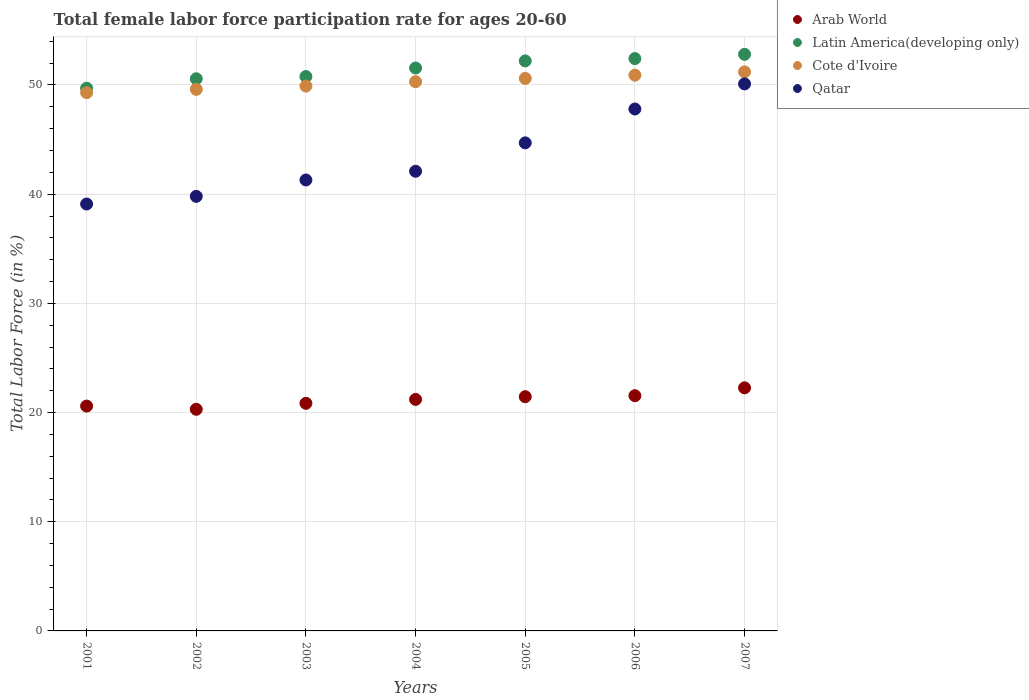What is the female labor force participation rate in Latin America(developing only) in 2006?
Give a very brief answer. 52.42. Across all years, what is the maximum female labor force participation rate in Latin America(developing only)?
Give a very brief answer. 52.81. Across all years, what is the minimum female labor force participation rate in Arab World?
Your response must be concise. 20.3. What is the total female labor force participation rate in Latin America(developing only) in the graph?
Give a very brief answer. 360.04. What is the difference between the female labor force participation rate in Arab World in 2003 and that in 2005?
Offer a very short reply. -0.61. What is the difference between the female labor force participation rate in Qatar in 2004 and the female labor force participation rate in Cote d'Ivoire in 2001?
Ensure brevity in your answer.  -7.2. What is the average female labor force participation rate in Arab World per year?
Your answer should be compact. 21.17. In the year 2003, what is the difference between the female labor force participation rate in Arab World and female labor force participation rate in Latin America(developing only)?
Your answer should be compact. -29.93. What is the ratio of the female labor force participation rate in Cote d'Ivoire in 2003 to that in 2004?
Ensure brevity in your answer.  0.99. What is the difference between the highest and the second highest female labor force participation rate in Qatar?
Make the answer very short. 2.3. What is the difference between the highest and the lowest female labor force participation rate in Arab World?
Give a very brief answer. 1.96. Is the sum of the female labor force participation rate in Qatar in 2002 and 2005 greater than the maximum female labor force participation rate in Latin America(developing only) across all years?
Your answer should be very brief. Yes. Is it the case that in every year, the sum of the female labor force participation rate in Qatar and female labor force participation rate in Latin America(developing only)  is greater than the female labor force participation rate in Arab World?
Offer a very short reply. Yes. Is the female labor force participation rate in Latin America(developing only) strictly less than the female labor force participation rate in Arab World over the years?
Make the answer very short. No. How many years are there in the graph?
Ensure brevity in your answer.  7. What is the difference between two consecutive major ticks on the Y-axis?
Offer a very short reply. 10. Does the graph contain any zero values?
Provide a succinct answer. No. Does the graph contain grids?
Provide a short and direct response. Yes. Where does the legend appear in the graph?
Your answer should be very brief. Top right. How are the legend labels stacked?
Offer a very short reply. Vertical. What is the title of the graph?
Provide a short and direct response. Total female labor force participation rate for ages 20-60. What is the label or title of the Y-axis?
Make the answer very short. Total Labor Force (in %). What is the Total Labor Force (in %) in Arab World in 2001?
Keep it short and to the point. 20.59. What is the Total Labor Force (in %) in Latin America(developing only) in 2001?
Your answer should be compact. 49.7. What is the Total Labor Force (in %) of Cote d'Ivoire in 2001?
Ensure brevity in your answer.  49.3. What is the Total Labor Force (in %) in Qatar in 2001?
Ensure brevity in your answer.  39.1. What is the Total Labor Force (in %) in Arab World in 2002?
Give a very brief answer. 20.3. What is the Total Labor Force (in %) of Latin America(developing only) in 2002?
Give a very brief answer. 50.57. What is the Total Labor Force (in %) in Cote d'Ivoire in 2002?
Offer a very short reply. 49.6. What is the Total Labor Force (in %) of Qatar in 2002?
Make the answer very short. 39.8. What is the Total Labor Force (in %) in Arab World in 2003?
Your answer should be very brief. 20.85. What is the Total Labor Force (in %) in Latin America(developing only) in 2003?
Your answer should be very brief. 50.77. What is the Total Labor Force (in %) of Cote d'Ivoire in 2003?
Your response must be concise. 49.9. What is the Total Labor Force (in %) of Qatar in 2003?
Your response must be concise. 41.3. What is the Total Labor Force (in %) of Arab World in 2004?
Your answer should be compact. 21.2. What is the Total Labor Force (in %) of Latin America(developing only) in 2004?
Ensure brevity in your answer.  51.55. What is the Total Labor Force (in %) of Cote d'Ivoire in 2004?
Ensure brevity in your answer.  50.3. What is the Total Labor Force (in %) in Qatar in 2004?
Provide a short and direct response. 42.1. What is the Total Labor Force (in %) in Arab World in 2005?
Offer a terse response. 21.45. What is the Total Labor Force (in %) of Latin America(developing only) in 2005?
Provide a short and direct response. 52.2. What is the Total Labor Force (in %) in Cote d'Ivoire in 2005?
Ensure brevity in your answer.  50.6. What is the Total Labor Force (in %) in Qatar in 2005?
Your answer should be very brief. 44.7. What is the Total Labor Force (in %) in Arab World in 2006?
Provide a short and direct response. 21.54. What is the Total Labor Force (in %) in Latin America(developing only) in 2006?
Your answer should be very brief. 52.42. What is the Total Labor Force (in %) of Cote d'Ivoire in 2006?
Provide a succinct answer. 50.9. What is the Total Labor Force (in %) of Qatar in 2006?
Offer a terse response. 47.8. What is the Total Labor Force (in %) of Arab World in 2007?
Provide a succinct answer. 22.26. What is the Total Labor Force (in %) in Latin America(developing only) in 2007?
Keep it short and to the point. 52.81. What is the Total Labor Force (in %) in Cote d'Ivoire in 2007?
Give a very brief answer. 51.2. What is the Total Labor Force (in %) of Qatar in 2007?
Your answer should be very brief. 50.1. Across all years, what is the maximum Total Labor Force (in %) of Arab World?
Ensure brevity in your answer.  22.26. Across all years, what is the maximum Total Labor Force (in %) of Latin America(developing only)?
Ensure brevity in your answer.  52.81. Across all years, what is the maximum Total Labor Force (in %) in Cote d'Ivoire?
Make the answer very short. 51.2. Across all years, what is the maximum Total Labor Force (in %) of Qatar?
Provide a short and direct response. 50.1. Across all years, what is the minimum Total Labor Force (in %) of Arab World?
Give a very brief answer. 20.3. Across all years, what is the minimum Total Labor Force (in %) of Latin America(developing only)?
Provide a succinct answer. 49.7. Across all years, what is the minimum Total Labor Force (in %) of Cote d'Ivoire?
Your answer should be compact. 49.3. Across all years, what is the minimum Total Labor Force (in %) in Qatar?
Offer a very short reply. 39.1. What is the total Total Labor Force (in %) in Arab World in the graph?
Offer a terse response. 148.2. What is the total Total Labor Force (in %) of Latin America(developing only) in the graph?
Make the answer very short. 360.04. What is the total Total Labor Force (in %) of Cote d'Ivoire in the graph?
Your answer should be compact. 351.8. What is the total Total Labor Force (in %) in Qatar in the graph?
Provide a succinct answer. 304.9. What is the difference between the Total Labor Force (in %) in Arab World in 2001 and that in 2002?
Offer a terse response. 0.29. What is the difference between the Total Labor Force (in %) of Latin America(developing only) in 2001 and that in 2002?
Provide a short and direct response. -0.87. What is the difference between the Total Labor Force (in %) in Cote d'Ivoire in 2001 and that in 2002?
Ensure brevity in your answer.  -0.3. What is the difference between the Total Labor Force (in %) of Arab World in 2001 and that in 2003?
Your response must be concise. -0.25. What is the difference between the Total Labor Force (in %) in Latin America(developing only) in 2001 and that in 2003?
Your answer should be very brief. -1.07. What is the difference between the Total Labor Force (in %) of Qatar in 2001 and that in 2003?
Give a very brief answer. -2.2. What is the difference between the Total Labor Force (in %) in Arab World in 2001 and that in 2004?
Your answer should be very brief. -0.61. What is the difference between the Total Labor Force (in %) in Latin America(developing only) in 2001 and that in 2004?
Your answer should be compact. -1.85. What is the difference between the Total Labor Force (in %) in Qatar in 2001 and that in 2004?
Keep it short and to the point. -3. What is the difference between the Total Labor Force (in %) of Arab World in 2001 and that in 2005?
Ensure brevity in your answer.  -0.86. What is the difference between the Total Labor Force (in %) in Latin America(developing only) in 2001 and that in 2005?
Ensure brevity in your answer.  -2.5. What is the difference between the Total Labor Force (in %) of Cote d'Ivoire in 2001 and that in 2005?
Provide a short and direct response. -1.3. What is the difference between the Total Labor Force (in %) of Qatar in 2001 and that in 2005?
Make the answer very short. -5.6. What is the difference between the Total Labor Force (in %) in Arab World in 2001 and that in 2006?
Provide a succinct answer. -0.95. What is the difference between the Total Labor Force (in %) of Latin America(developing only) in 2001 and that in 2006?
Keep it short and to the point. -2.72. What is the difference between the Total Labor Force (in %) of Arab World in 2001 and that in 2007?
Keep it short and to the point. -1.67. What is the difference between the Total Labor Force (in %) in Latin America(developing only) in 2001 and that in 2007?
Your answer should be compact. -3.11. What is the difference between the Total Labor Force (in %) in Qatar in 2001 and that in 2007?
Ensure brevity in your answer.  -11. What is the difference between the Total Labor Force (in %) in Arab World in 2002 and that in 2003?
Provide a short and direct response. -0.55. What is the difference between the Total Labor Force (in %) in Latin America(developing only) in 2002 and that in 2003?
Provide a short and direct response. -0.2. What is the difference between the Total Labor Force (in %) of Qatar in 2002 and that in 2003?
Make the answer very short. -1.5. What is the difference between the Total Labor Force (in %) in Arab World in 2002 and that in 2004?
Ensure brevity in your answer.  -0.9. What is the difference between the Total Labor Force (in %) of Latin America(developing only) in 2002 and that in 2004?
Your answer should be compact. -0.98. What is the difference between the Total Labor Force (in %) in Cote d'Ivoire in 2002 and that in 2004?
Your response must be concise. -0.7. What is the difference between the Total Labor Force (in %) of Qatar in 2002 and that in 2004?
Offer a very short reply. -2.3. What is the difference between the Total Labor Force (in %) in Arab World in 2002 and that in 2005?
Ensure brevity in your answer.  -1.15. What is the difference between the Total Labor Force (in %) of Latin America(developing only) in 2002 and that in 2005?
Provide a succinct answer. -1.63. What is the difference between the Total Labor Force (in %) of Arab World in 2002 and that in 2006?
Offer a very short reply. -1.24. What is the difference between the Total Labor Force (in %) of Latin America(developing only) in 2002 and that in 2006?
Keep it short and to the point. -1.85. What is the difference between the Total Labor Force (in %) in Cote d'Ivoire in 2002 and that in 2006?
Offer a terse response. -1.3. What is the difference between the Total Labor Force (in %) of Arab World in 2002 and that in 2007?
Your response must be concise. -1.96. What is the difference between the Total Labor Force (in %) of Latin America(developing only) in 2002 and that in 2007?
Provide a succinct answer. -2.24. What is the difference between the Total Labor Force (in %) of Arab World in 2003 and that in 2004?
Offer a terse response. -0.36. What is the difference between the Total Labor Force (in %) of Latin America(developing only) in 2003 and that in 2004?
Offer a very short reply. -0.78. What is the difference between the Total Labor Force (in %) in Cote d'Ivoire in 2003 and that in 2004?
Offer a very short reply. -0.4. What is the difference between the Total Labor Force (in %) in Arab World in 2003 and that in 2005?
Make the answer very short. -0.61. What is the difference between the Total Labor Force (in %) of Latin America(developing only) in 2003 and that in 2005?
Your response must be concise. -1.43. What is the difference between the Total Labor Force (in %) in Arab World in 2003 and that in 2006?
Ensure brevity in your answer.  -0.7. What is the difference between the Total Labor Force (in %) of Latin America(developing only) in 2003 and that in 2006?
Offer a very short reply. -1.65. What is the difference between the Total Labor Force (in %) in Cote d'Ivoire in 2003 and that in 2006?
Provide a succinct answer. -1. What is the difference between the Total Labor Force (in %) in Qatar in 2003 and that in 2006?
Provide a succinct answer. -6.5. What is the difference between the Total Labor Force (in %) of Arab World in 2003 and that in 2007?
Provide a succinct answer. -1.42. What is the difference between the Total Labor Force (in %) in Latin America(developing only) in 2003 and that in 2007?
Make the answer very short. -2.04. What is the difference between the Total Labor Force (in %) of Cote d'Ivoire in 2003 and that in 2007?
Your answer should be compact. -1.3. What is the difference between the Total Labor Force (in %) of Qatar in 2003 and that in 2007?
Offer a terse response. -8.8. What is the difference between the Total Labor Force (in %) of Arab World in 2004 and that in 2005?
Offer a terse response. -0.25. What is the difference between the Total Labor Force (in %) in Latin America(developing only) in 2004 and that in 2005?
Provide a succinct answer. -0.65. What is the difference between the Total Labor Force (in %) of Cote d'Ivoire in 2004 and that in 2005?
Your answer should be compact. -0.3. What is the difference between the Total Labor Force (in %) of Qatar in 2004 and that in 2005?
Offer a terse response. -2.6. What is the difference between the Total Labor Force (in %) in Arab World in 2004 and that in 2006?
Offer a terse response. -0.34. What is the difference between the Total Labor Force (in %) of Latin America(developing only) in 2004 and that in 2006?
Your answer should be very brief. -0.86. What is the difference between the Total Labor Force (in %) in Cote d'Ivoire in 2004 and that in 2006?
Ensure brevity in your answer.  -0.6. What is the difference between the Total Labor Force (in %) in Qatar in 2004 and that in 2006?
Your answer should be compact. -5.7. What is the difference between the Total Labor Force (in %) in Arab World in 2004 and that in 2007?
Provide a succinct answer. -1.06. What is the difference between the Total Labor Force (in %) in Latin America(developing only) in 2004 and that in 2007?
Provide a succinct answer. -1.25. What is the difference between the Total Labor Force (in %) of Arab World in 2005 and that in 2006?
Offer a terse response. -0.09. What is the difference between the Total Labor Force (in %) of Latin America(developing only) in 2005 and that in 2006?
Offer a terse response. -0.21. What is the difference between the Total Labor Force (in %) in Cote d'Ivoire in 2005 and that in 2006?
Give a very brief answer. -0.3. What is the difference between the Total Labor Force (in %) in Arab World in 2005 and that in 2007?
Your response must be concise. -0.81. What is the difference between the Total Labor Force (in %) of Latin America(developing only) in 2005 and that in 2007?
Your response must be concise. -0.6. What is the difference between the Total Labor Force (in %) of Arab World in 2006 and that in 2007?
Ensure brevity in your answer.  -0.72. What is the difference between the Total Labor Force (in %) in Latin America(developing only) in 2006 and that in 2007?
Your answer should be very brief. -0.39. What is the difference between the Total Labor Force (in %) of Cote d'Ivoire in 2006 and that in 2007?
Offer a very short reply. -0.3. What is the difference between the Total Labor Force (in %) in Qatar in 2006 and that in 2007?
Give a very brief answer. -2.3. What is the difference between the Total Labor Force (in %) in Arab World in 2001 and the Total Labor Force (in %) in Latin America(developing only) in 2002?
Your answer should be compact. -29.98. What is the difference between the Total Labor Force (in %) in Arab World in 2001 and the Total Labor Force (in %) in Cote d'Ivoire in 2002?
Keep it short and to the point. -29.01. What is the difference between the Total Labor Force (in %) of Arab World in 2001 and the Total Labor Force (in %) of Qatar in 2002?
Make the answer very short. -19.21. What is the difference between the Total Labor Force (in %) of Latin America(developing only) in 2001 and the Total Labor Force (in %) of Cote d'Ivoire in 2002?
Offer a terse response. 0.1. What is the difference between the Total Labor Force (in %) in Latin America(developing only) in 2001 and the Total Labor Force (in %) in Qatar in 2002?
Make the answer very short. 9.9. What is the difference between the Total Labor Force (in %) of Cote d'Ivoire in 2001 and the Total Labor Force (in %) of Qatar in 2002?
Your answer should be compact. 9.5. What is the difference between the Total Labor Force (in %) in Arab World in 2001 and the Total Labor Force (in %) in Latin America(developing only) in 2003?
Your response must be concise. -30.18. What is the difference between the Total Labor Force (in %) of Arab World in 2001 and the Total Labor Force (in %) of Cote d'Ivoire in 2003?
Offer a very short reply. -29.31. What is the difference between the Total Labor Force (in %) of Arab World in 2001 and the Total Labor Force (in %) of Qatar in 2003?
Give a very brief answer. -20.71. What is the difference between the Total Labor Force (in %) in Latin America(developing only) in 2001 and the Total Labor Force (in %) in Cote d'Ivoire in 2003?
Your answer should be very brief. -0.2. What is the difference between the Total Labor Force (in %) in Latin America(developing only) in 2001 and the Total Labor Force (in %) in Qatar in 2003?
Give a very brief answer. 8.4. What is the difference between the Total Labor Force (in %) of Arab World in 2001 and the Total Labor Force (in %) of Latin America(developing only) in 2004?
Keep it short and to the point. -30.96. What is the difference between the Total Labor Force (in %) in Arab World in 2001 and the Total Labor Force (in %) in Cote d'Ivoire in 2004?
Your response must be concise. -29.71. What is the difference between the Total Labor Force (in %) of Arab World in 2001 and the Total Labor Force (in %) of Qatar in 2004?
Ensure brevity in your answer.  -21.51. What is the difference between the Total Labor Force (in %) in Latin America(developing only) in 2001 and the Total Labor Force (in %) in Cote d'Ivoire in 2004?
Give a very brief answer. -0.6. What is the difference between the Total Labor Force (in %) in Latin America(developing only) in 2001 and the Total Labor Force (in %) in Qatar in 2004?
Offer a terse response. 7.6. What is the difference between the Total Labor Force (in %) in Cote d'Ivoire in 2001 and the Total Labor Force (in %) in Qatar in 2004?
Offer a terse response. 7.2. What is the difference between the Total Labor Force (in %) of Arab World in 2001 and the Total Labor Force (in %) of Latin America(developing only) in 2005?
Ensure brevity in your answer.  -31.61. What is the difference between the Total Labor Force (in %) of Arab World in 2001 and the Total Labor Force (in %) of Cote d'Ivoire in 2005?
Provide a short and direct response. -30.01. What is the difference between the Total Labor Force (in %) of Arab World in 2001 and the Total Labor Force (in %) of Qatar in 2005?
Keep it short and to the point. -24.11. What is the difference between the Total Labor Force (in %) of Latin America(developing only) in 2001 and the Total Labor Force (in %) of Cote d'Ivoire in 2005?
Make the answer very short. -0.9. What is the difference between the Total Labor Force (in %) in Latin America(developing only) in 2001 and the Total Labor Force (in %) in Qatar in 2005?
Keep it short and to the point. 5. What is the difference between the Total Labor Force (in %) in Cote d'Ivoire in 2001 and the Total Labor Force (in %) in Qatar in 2005?
Keep it short and to the point. 4.6. What is the difference between the Total Labor Force (in %) of Arab World in 2001 and the Total Labor Force (in %) of Latin America(developing only) in 2006?
Ensure brevity in your answer.  -31.83. What is the difference between the Total Labor Force (in %) in Arab World in 2001 and the Total Labor Force (in %) in Cote d'Ivoire in 2006?
Your response must be concise. -30.31. What is the difference between the Total Labor Force (in %) in Arab World in 2001 and the Total Labor Force (in %) in Qatar in 2006?
Keep it short and to the point. -27.21. What is the difference between the Total Labor Force (in %) of Latin America(developing only) in 2001 and the Total Labor Force (in %) of Cote d'Ivoire in 2006?
Offer a very short reply. -1.2. What is the difference between the Total Labor Force (in %) in Latin America(developing only) in 2001 and the Total Labor Force (in %) in Qatar in 2006?
Your response must be concise. 1.9. What is the difference between the Total Labor Force (in %) in Arab World in 2001 and the Total Labor Force (in %) in Latin America(developing only) in 2007?
Offer a terse response. -32.22. What is the difference between the Total Labor Force (in %) of Arab World in 2001 and the Total Labor Force (in %) of Cote d'Ivoire in 2007?
Make the answer very short. -30.61. What is the difference between the Total Labor Force (in %) in Arab World in 2001 and the Total Labor Force (in %) in Qatar in 2007?
Ensure brevity in your answer.  -29.51. What is the difference between the Total Labor Force (in %) in Latin America(developing only) in 2001 and the Total Labor Force (in %) in Cote d'Ivoire in 2007?
Provide a short and direct response. -1.5. What is the difference between the Total Labor Force (in %) in Latin America(developing only) in 2001 and the Total Labor Force (in %) in Qatar in 2007?
Ensure brevity in your answer.  -0.4. What is the difference between the Total Labor Force (in %) in Cote d'Ivoire in 2001 and the Total Labor Force (in %) in Qatar in 2007?
Your answer should be very brief. -0.8. What is the difference between the Total Labor Force (in %) of Arab World in 2002 and the Total Labor Force (in %) of Latin America(developing only) in 2003?
Keep it short and to the point. -30.48. What is the difference between the Total Labor Force (in %) of Arab World in 2002 and the Total Labor Force (in %) of Cote d'Ivoire in 2003?
Make the answer very short. -29.6. What is the difference between the Total Labor Force (in %) of Arab World in 2002 and the Total Labor Force (in %) of Qatar in 2003?
Your answer should be very brief. -21. What is the difference between the Total Labor Force (in %) in Latin America(developing only) in 2002 and the Total Labor Force (in %) in Cote d'Ivoire in 2003?
Ensure brevity in your answer.  0.67. What is the difference between the Total Labor Force (in %) of Latin America(developing only) in 2002 and the Total Labor Force (in %) of Qatar in 2003?
Ensure brevity in your answer.  9.27. What is the difference between the Total Labor Force (in %) in Cote d'Ivoire in 2002 and the Total Labor Force (in %) in Qatar in 2003?
Ensure brevity in your answer.  8.3. What is the difference between the Total Labor Force (in %) of Arab World in 2002 and the Total Labor Force (in %) of Latin America(developing only) in 2004?
Give a very brief answer. -31.26. What is the difference between the Total Labor Force (in %) of Arab World in 2002 and the Total Labor Force (in %) of Cote d'Ivoire in 2004?
Offer a terse response. -30. What is the difference between the Total Labor Force (in %) of Arab World in 2002 and the Total Labor Force (in %) of Qatar in 2004?
Ensure brevity in your answer.  -21.8. What is the difference between the Total Labor Force (in %) of Latin America(developing only) in 2002 and the Total Labor Force (in %) of Cote d'Ivoire in 2004?
Provide a short and direct response. 0.27. What is the difference between the Total Labor Force (in %) in Latin America(developing only) in 2002 and the Total Labor Force (in %) in Qatar in 2004?
Your answer should be compact. 8.47. What is the difference between the Total Labor Force (in %) in Cote d'Ivoire in 2002 and the Total Labor Force (in %) in Qatar in 2004?
Offer a very short reply. 7.5. What is the difference between the Total Labor Force (in %) of Arab World in 2002 and the Total Labor Force (in %) of Latin America(developing only) in 2005?
Your response must be concise. -31.91. What is the difference between the Total Labor Force (in %) of Arab World in 2002 and the Total Labor Force (in %) of Cote d'Ivoire in 2005?
Your answer should be very brief. -30.3. What is the difference between the Total Labor Force (in %) in Arab World in 2002 and the Total Labor Force (in %) in Qatar in 2005?
Ensure brevity in your answer.  -24.4. What is the difference between the Total Labor Force (in %) of Latin America(developing only) in 2002 and the Total Labor Force (in %) of Cote d'Ivoire in 2005?
Keep it short and to the point. -0.03. What is the difference between the Total Labor Force (in %) in Latin America(developing only) in 2002 and the Total Labor Force (in %) in Qatar in 2005?
Your answer should be compact. 5.87. What is the difference between the Total Labor Force (in %) in Cote d'Ivoire in 2002 and the Total Labor Force (in %) in Qatar in 2005?
Offer a very short reply. 4.9. What is the difference between the Total Labor Force (in %) in Arab World in 2002 and the Total Labor Force (in %) in Latin America(developing only) in 2006?
Offer a terse response. -32.12. What is the difference between the Total Labor Force (in %) in Arab World in 2002 and the Total Labor Force (in %) in Cote d'Ivoire in 2006?
Your answer should be very brief. -30.6. What is the difference between the Total Labor Force (in %) of Arab World in 2002 and the Total Labor Force (in %) of Qatar in 2006?
Offer a very short reply. -27.5. What is the difference between the Total Labor Force (in %) in Latin America(developing only) in 2002 and the Total Labor Force (in %) in Cote d'Ivoire in 2006?
Your answer should be very brief. -0.33. What is the difference between the Total Labor Force (in %) of Latin America(developing only) in 2002 and the Total Labor Force (in %) of Qatar in 2006?
Your answer should be compact. 2.77. What is the difference between the Total Labor Force (in %) in Cote d'Ivoire in 2002 and the Total Labor Force (in %) in Qatar in 2006?
Your answer should be compact. 1.8. What is the difference between the Total Labor Force (in %) of Arab World in 2002 and the Total Labor Force (in %) of Latin America(developing only) in 2007?
Offer a very short reply. -32.51. What is the difference between the Total Labor Force (in %) of Arab World in 2002 and the Total Labor Force (in %) of Cote d'Ivoire in 2007?
Provide a short and direct response. -30.9. What is the difference between the Total Labor Force (in %) in Arab World in 2002 and the Total Labor Force (in %) in Qatar in 2007?
Provide a succinct answer. -29.8. What is the difference between the Total Labor Force (in %) in Latin America(developing only) in 2002 and the Total Labor Force (in %) in Cote d'Ivoire in 2007?
Make the answer very short. -0.63. What is the difference between the Total Labor Force (in %) in Latin America(developing only) in 2002 and the Total Labor Force (in %) in Qatar in 2007?
Provide a succinct answer. 0.47. What is the difference between the Total Labor Force (in %) of Arab World in 2003 and the Total Labor Force (in %) of Latin America(developing only) in 2004?
Offer a very short reply. -30.71. What is the difference between the Total Labor Force (in %) in Arab World in 2003 and the Total Labor Force (in %) in Cote d'Ivoire in 2004?
Offer a terse response. -29.45. What is the difference between the Total Labor Force (in %) of Arab World in 2003 and the Total Labor Force (in %) of Qatar in 2004?
Provide a short and direct response. -21.25. What is the difference between the Total Labor Force (in %) of Latin America(developing only) in 2003 and the Total Labor Force (in %) of Cote d'Ivoire in 2004?
Make the answer very short. 0.47. What is the difference between the Total Labor Force (in %) in Latin America(developing only) in 2003 and the Total Labor Force (in %) in Qatar in 2004?
Make the answer very short. 8.67. What is the difference between the Total Labor Force (in %) in Arab World in 2003 and the Total Labor Force (in %) in Latin America(developing only) in 2005?
Keep it short and to the point. -31.36. What is the difference between the Total Labor Force (in %) in Arab World in 2003 and the Total Labor Force (in %) in Cote d'Ivoire in 2005?
Your answer should be compact. -29.75. What is the difference between the Total Labor Force (in %) of Arab World in 2003 and the Total Labor Force (in %) of Qatar in 2005?
Provide a short and direct response. -23.85. What is the difference between the Total Labor Force (in %) of Latin America(developing only) in 2003 and the Total Labor Force (in %) of Cote d'Ivoire in 2005?
Make the answer very short. 0.17. What is the difference between the Total Labor Force (in %) in Latin America(developing only) in 2003 and the Total Labor Force (in %) in Qatar in 2005?
Offer a very short reply. 6.07. What is the difference between the Total Labor Force (in %) of Arab World in 2003 and the Total Labor Force (in %) of Latin America(developing only) in 2006?
Make the answer very short. -31.57. What is the difference between the Total Labor Force (in %) of Arab World in 2003 and the Total Labor Force (in %) of Cote d'Ivoire in 2006?
Your response must be concise. -30.05. What is the difference between the Total Labor Force (in %) of Arab World in 2003 and the Total Labor Force (in %) of Qatar in 2006?
Keep it short and to the point. -26.95. What is the difference between the Total Labor Force (in %) in Latin America(developing only) in 2003 and the Total Labor Force (in %) in Cote d'Ivoire in 2006?
Offer a very short reply. -0.13. What is the difference between the Total Labor Force (in %) of Latin America(developing only) in 2003 and the Total Labor Force (in %) of Qatar in 2006?
Give a very brief answer. 2.97. What is the difference between the Total Labor Force (in %) in Cote d'Ivoire in 2003 and the Total Labor Force (in %) in Qatar in 2006?
Your response must be concise. 2.1. What is the difference between the Total Labor Force (in %) in Arab World in 2003 and the Total Labor Force (in %) in Latin America(developing only) in 2007?
Provide a short and direct response. -31.96. What is the difference between the Total Labor Force (in %) in Arab World in 2003 and the Total Labor Force (in %) in Cote d'Ivoire in 2007?
Give a very brief answer. -30.35. What is the difference between the Total Labor Force (in %) of Arab World in 2003 and the Total Labor Force (in %) of Qatar in 2007?
Ensure brevity in your answer.  -29.25. What is the difference between the Total Labor Force (in %) in Latin America(developing only) in 2003 and the Total Labor Force (in %) in Cote d'Ivoire in 2007?
Your response must be concise. -0.43. What is the difference between the Total Labor Force (in %) in Latin America(developing only) in 2003 and the Total Labor Force (in %) in Qatar in 2007?
Keep it short and to the point. 0.67. What is the difference between the Total Labor Force (in %) in Cote d'Ivoire in 2003 and the Total Labor Force (in %) in Qatar in 2007?
Provide a succinct answer. -0.2. What is the difference between the Total Labor Force (in %) in Arab World in 2004 and the Total Labor Force (in %) in Latin America(developing only) in 2005?
Offer a terse response. -31. What is the difference between the Total Labor Force (in %) in Arab World in 2004 and the Total Labor Force (in %) in Cote d'Ivoire in 2005?
Give a very brief answer. -29.4. What is the difference between the Total Labor Force (in %) in Arab World in 2004 and the Total Labor Force (in %) in Qatar in 2005?
Make the answer very short. -23.5. What is the difference between the Total Labor Force (in %) in Latin America(developing only) in 2004 and the Total Labor Force (in %) in Cote d'Ivoire in 2005?
Provide a short and direct response. 0.95. What is the difference between the Total Labor Force (in %) in Latin America(developing only) in 2004 and the Total Labor Force (in %) in Qatar in 2005?
Ensure brevity in your answer.  6.85. What is the difference between the Total Labor Force (in %) in Cote d'Ivoire in 2004 and the Total Labor Force (in %) in Qatar in 2005?
Provide a succinct answer. 5.6. What is the difference between the Total Labor Force (in %) in Arab World in 2004 and the Total Labor Force (in %) in Latin America(developing only) in 2006?
Provide a succinct answer. -31.22. What is the difference between the Total Labor Force (in %) of Arab World in 2004 and the Total Labor Force (in %) of Cote d'Ivoire in 2006?
Offer a very short reply. -29.7. What is the difference between the Total Labor Force (in %) in Arab World in 2004 and the Total Labor Force (in %) in Qatar in 2006?
Your answer should be very brief. -26.6. What is the difference between the Total Labor Force (in %) of Latin America(developing only) in 2004 and the Total Labor Force (in %) of Cote d'Ivoire in 2006?
Provide a succinct answer. 0.65. What is the difference between the Total Labor Force (in %) in Latin America(developing only) in 2004 and the Total Labor Force (in %) in Qatar in 2006?
Your answer should be very brief. 3.75. What is the difference between the Total Labor Force (in %) in Arab World in 2004 and the Total Labor Force (in %) in Latin America(developing only) in 2007?
Provide a short and direct response. -31.61. What is the difference between the Total Labor Force (in %) of Arab World in 2004 and the Total Labor Force (in %) of Cote d'Ivoire in 2007?
Keep it short and to the point. -30. What is the difference between the Total Labor Force (in %) in Arab World in 2004 and the Total Labor Force (in %) in Qatar in 2007?
Your answer should be compact. -28.9. What is the difference between the Total Labor Force (in %) in Latin America(developing only) in 2004 and the Total Labor Force (in %) in Cote d'Ivoire in 2007?
Your answer should be compact. 0.35. What is the difference between the Total Labor Force (in %) in Latin America(developing only) in 2004 and the Total Labor Force (in %) in Qatar in 2007?
Offer a very short reply. 1.45. What is the difference between the Total Labor Force (in %) in Arab World in 2005 and the Total Labor Force (in %) in Latin America(developing only) in 2006?
Keep it short and to the point. -30.97. What is the difference between the Total Labor Force (in %) in Arab World in 2005 and the Total Labor Force (in %) in Cote d'Ivoire in 2006?
Ensure brevity in your answer.  -29.45. What is the difference between the Total Labor Force (in %) in Arab World in 2005 and the Total Labor Force (in %) in Qatar in 2006?
Offer a very short reply. -26.35. What is the difference between the Total Labor Force (in %) of Latin America(developing only) in 2005 and the Total Labor Force (in %) of Cote d'Ivoire in 2006?
Your response must be concise. 1.3. What is the difference between the Total Labor Force (in %) in Latin America(developing only) in 2005 and the Total Labor Force (in %) in Qatar in 2006?
Make the answer very short. 4.4. What is the difference between the Total Labor Force (in %) of Cote d'Ivoire in 2005 and the Total Labor Force (in %) of Qatar in 2006?
Make the answer very short. 2.8. What is the difference between the Total Labor Force (in %) of Arab World in 2005 and the Total Labor Force (in %) of Latin America(developing only) in 2007?
Offer a terse response. -31.36. What is the difference between the Total Labor Force (in %) in Arab World in 2005 and the Total Labor Force (in %) in Cote d'Ivoire in 2007?
Give a very brief answer. -29.75. What is the difference between the Total Labor Force (in %) in Arab World in 2005 and the Total Labor Force (in %) in Qatar in 2007?
Offer a terse response. -28.65. What is the difference between the Total Labor Force (in %) in Latin America(developing only) in 2005 and the Total Labor Force (in %) in Cote d'Ivoire in 2007?
Make the answer very short. 1. What is the difference between the Total Labor Force (in %) of Latin America(developing only) in 2005 and the Total Labor Force (in %) of Qatar in 2007?
Make the answer very short. 2.1. What is the difference between the Total Labor Force (in %) of Cote d'Ivoire in 2005 and the Total Labor Force (in %) of Qatar in 2007?
Give a very brief answer. 0.5. What is the difference between the Total Labor Force (in %) of Arab World in 2006 and the Total Labor Force (in %) of Latin America(developing only) in 2007?
Ensure brevity in your answer.  -31.27. What is the difference between the Total Labor Force (in %) of Arab World in 2006 and the Total Labor Force (in %) of Cote d'Ivoire in 2007?
Your answer should be compact. -29.66. What is the difference between the Total Labor Force (in %) in Arab World in 2006 and the Total Labor Force (in %) in Qatar in 2007?
Provide a succinct answer. -28.56. What is the difference between the Total Labor Force (in %) in Latin America(developing only) in 2006 and the Total Labor Force (in %) in Cote d'Ivoire in 2007?
Your answer should be compact. 1.22. What is the difference between the Total Labor Force (in %) in Latin America(developing only) in 2006 and the Total Labor Force (in %) in Qatar in 2007?
Your answer should be compact. 2.32. What is the average Total Labor Force (in %) in Arab World per year?
Your answer should be compact. 21.17. What is the average Total Labor Force (in %) in Latin America(developing only) per year?
Provide a succinct answer. 51.43. What is the average Total Labor Force (in %) in Cote d'Ivoire per year?
Offer a very short reply. 50.26. What is the average Total Labor Force (in %) in Qatar per year?
Make the answer very short. 43.56. In the year 2001, what is the difference between the Total Labor Force (in %) in Arab World and Total Labor Force (in %) in Latin America(developing only)?
Give a very brief answer. -29.11. In the year 2001, what is the difference between the Total Labor Force (in %) of Arab World and Total Labor Force (in %) of Cote d'Ivoire?
Offer a very short reply. -28.71. In the year 2001, what is the difference between the Total Labor Force (in %) in Arab World and Total Labor Force (in %) in Qatar?
Keep it short and to the point. -18.51. In the year 2001, what is the difference between the Total Labor Force (in %) in Latin America(developing only) and Total Labor Force (in %) in Cote d'Ivoire?
Give a very brief answer. 0.4. In the year 2001, what is the difference between the Total Labor Force (in %) in Latin America(developing only) and Total Labor Force (in %) in Qatar?
Your answer should be very brief. 10.6. In the year 2002, what is the difference between the Total Labor Force (in %) of Arab World and Total Labor Force (in %) of Latin America(developing only)?
Provide a short and direct response. -30.27. In the year 2002, what is the difference between the Total Labor Force (in %) in Arab World and Total Labor Force (in %) in Cote d'Ivoire?
Offer a terse response. -29.3. In the year 2002, what is the difference between the Total Labor Force (in %) of Arab World and Total Labor Force (in %) of Qatar?
Your answer should be very brief. -19.5. In the year 2002, what is the difference between the Total Labor Force (in %) of Latin America(developing only) and Total Labor Force (in %) of Cote d'Ivoire?
Your answer should be very brief. 0.97. In the year 2002, what is the difference between the Total Labor Force (in %) in Latin America(developing only) and Total Labor Force (in %) in Qatar?
Make the answer very short. 10.77. In the year 2003, what is the difference between the Total Labor Force (in %) in Arab World and Total Labor Force (in %) in Latin America(developing only)?
Offer a terse response. -29.93. In the year 2003, what is the difference between the Total Labor Force (in %) of Arab World and Total Labor Force (in %) of Cote d'Ivoire?
Make the answer very short. -29.05. In the year 2003, what is the difference between the Total Labor Force (in %) of Arab World and Total Labor Force (in %) of Qatar?
Keep it short and to the point. -20.45. In the year 2003, what is the difference between the Total Labor Force (in %) in Latin America(developing only) and Total Labor Force (in %) in Cote d'Ivoire?
Make the answer very short. 0.87. In the year 2003, what is the difference between the Total Labor Force (in %) of Latin America(developing only) and Total Labor Force (in %) of Qatar?
Make the answer very short. 9.47. In the year 2003, what is the difference between the Total Labor Force (in %) of Cote d'Ivoire and Total Labor Force (in %) of Qatar?
Your answer should be very brief. 8.6. In the year 2004, what is the difference between the Total Labor Force (in %) in Arab World and Total Labor Force (in %) in Latin America(developing only)?
Your answer should be compact. -30.35. In the year 2004, what is the difference between the Total Labor Force (in %) in Arab World and Total Labor Force (in %) in Cote d'Ivoire?
Provide a succinct answer. -29.1. In the year 2004, what is the difference between the Total Labor Force (in %) of Arab World and Total Labor Force (in %) of Qatar?
Ensure brevity in your answer.  -20.9. In the year 2004, what is the difference between the Total Labor Force (in %) of Latin America(developing only) and Total Labor Force (in %) of Cote d'Ivoire?
Keep it short and to the point. 1.25. In the year 2004, what is the difference between the Total Labor Force (in %) of Latin America(developing only) and Total Labor Force (in %) of Qatar?
Your answer should be compact. 9.45. In the year 2004, what is the difference between the Total Labor Force (in %) in Cote d'Ivoire and Total Labor Force (in %) in Qatar?
Your answer should be very brief. 8.2. In the year 2005, what is the difference between the Total Labor Force (in %) of Arab World and Total Labor Force (in %) of Latin America(developing only)?
Offer a terse response. -30.75. In the year 2005, what is the difference between the Total Labor Force (in %) in Arab World and Total Labor Force (in %) in Cote d'Ivoire?
Provide a short and direct response. -29.15. In the year 2005, what is the difference between the Total Labor Force (in %) of Arab World and Total Labor Force (in %) of Qatar?
Make the answer very short. -23.25. In the year 2005, what is the difference between the Total Labor Force (in %) in Latin America(developing only) and Total Labor Force (in %) in Cote d'Ivoire?
Your answer should be compact. 1.6. In the year 2005, what is the difference between the Total Labor Force (in %) of Latin America(developing only) and Total Labor Force (in %) of Qatar?
Give a very brief answer. 7.5. In the year 2005, what is the difference between the Total Labor Force (in %) of Cote d'Ivoire and Total Labor Force (in %) of Qatar?
Your answer should be compact. 5.9. In the year 2006, what is the difference between the Total Labor Force (in %) in Arab World and Total Labor Force (in %) in Latin America(developing only)?
Offer a very short reply. -30.88. In the year 2006, what is the difference between the Total Labor Force (in %) in Arab World and Total Labor Force (in %) in Cote d'Ivoire?
Give a very brief answer. -29.36. In the year 2006, what is the difference between the Total Labor Force (in %) of Arab World and Total Labor Force (in %) of Qatar?
Provide a short and direct response. -26.26. In the year 2006, what is the difference between the Total Labor Force (in %) of Latin America(developing only) and Total Labor Force (in %) of Cote d'Ivoire?
Provide a succinct answer. 1.52. In the year 2006, what is the difference between the Total Labor Force (in %) of Latin America(developing only) and Total Labor Force (in %) of Qatar?
Your answer should be very brief. 4.62. In the year 2007, what is the difference between the Total Labor Force (in %) in Arab World and Total Labor Force (in %) in Latin America(developing only)?
Your answer should be very brief. -30.55. In the year 2007, what is the difference between the Total Labor Force (in %) of Arab World and Total Labor Force (in %) of Cote d'Ivoire?
Give a very brief answer. -28.94. In the year 2007, what is the difference between the Total Labor Force (in %) of Arab World and Total Labor Force (in %) of Qatar?
Offer a terse response. -27.84. In the year 2007, what is the difference between the Total Labor Force (in %) of Latin America(developing only) and Total Labor Force (in %) of Cote d'Ivoire?
Make the answer very short. 1.61. In the year 2007, what is the difference between the Total Labor Force (in %) of Latin America(developing only) and Total Labor Force (in %) of Qatar?
Ensure brevity in your answer.  2.71. In the year 2007, what is the difference between the Total Labor Force (in %) of Cote d'Ivoire and Total Labor Force (in %) of Qatar?
Make the answer very short. 1.1. What is the ratio of the Total Labor Force (in %) in Arab World in 2001 to that in 2002?
Provide a short and direct response. 1.01. What is the ratio of the Total Labor Force (in %) in Latin America(developing only) in 2001 to that in 2002?
Your response must be concise. 0.98. What is the ratio of the Total Labor Force (in %) in Cote d'Ivoire in 2001 to that in 2002?
Your answer should be very brief. 0.99. What is the ratio of the Total Labor Force (in %) in Qatar in 2001 to that in 2002?
Your response must be concise. 0.98. What is the ratio of the Total Labor Force (in %) in Arab World in 2001 to that in 2003?
Your answer should be compact. 0.99. What is the ratio of the Total Labor Force (in %) of Latin America(developing only) in 2001 to that in 2003?
Give a very brief answer. 0.98. What is the ratio of the Total Labor Force (in %) in Cote d'Ivoire in 2001 to that in 2003?
Offer a terse response. 0.99. What is the ratio of the Total Labor Force (in %) of Qatar in 2001 to that in 2003?
Your answer should be compact. 0.95. What is the ratio of the Total Labor Force (in %) of Arab World in 2001 to that in 2004?
Provide a short and direct response. 0.97. What is the ratio of the Total Labor Force (in %) of Latin America(developing only) in 2001 to that in 2004?
Keep it short and to the point. 0.96. What is the ratio of the Total Labor Force (in %) of Cote d'Ivoire in 2001 to that in 2004?
Make the answer very short. 0.98. What is the ratio of the Total Labor Force (in %) of Qatar in 2001 to that in 2004?
Provide a succinct answer. 0.93. What is the ratio of the Total Labor Force (in %) of Arab World in 2001 to that in 2005?
Your answer should be compact. 0.96. What is the ratio of the Total Labor Force (in %) of Latin America(developing only) in 2001 to that in 2005?
Offer a terse response. 0.95. What is the ratio of the Total Labor Force (in %) in Cote d'Ivoire in 2001 to that in 2005?
Your answer should be very brief. 0.97. What is the ratio of the Total Labor Force (in %) of Qatar in 2001 to that in 2005?
Your answer should be compact. 0.87. What is the ratio of the Total Labor Force (in %) of Arab World in 2001 to that in 2006?
Your answer should be very brief. 0.96. What is the ratio of the Total Labor Force (in %) in Latin America(developing only) in 2001 to that in 2006?
Give a very brief answer. 0.95. What is the ratio of the Total Labor Force (in %) in Cote d'Ivoire in 2001 to that in 2006?
Ensure brevity in your answer.  0.97. What is the ratio of the Total Labor Force (in %) in Qatar in 2001 to that in 2006?
Your answer should be very brief. 0.82. What is the ratio of the Total Labor Force (in %) in Arab World in 2001 to that in 2007?
Make the answer very short. 0.93. What is the ratio of the Total Labor Force (in %) of Latin America(developing only) in 2001 to that in 2007?
Offer a terse response. 0.94. What is the ratio of the Total Labor Force (in %) of Cote d'Ivoire in 2001 to that in 2007?
Keep it short and to the point. 0.96. What is the ratio of the Total Labor Force (in %) of Qatar in 2001 to that in 2007?
Offer a very short reply. 0.78. What is the ratio of the Total Labor Force (in %) of Arab World in 2002 to that in 2003?
Offer a very short reply. 0.97. What is the ratio of the Total Labor Force (in %) in Latin America(developing only) in 2002 to that in 2003?
Make the answer very short. 1. What is the ratio of the Total Labor Force (in %) in Qatar in 2002 to that in 2003?
Keep it short and to the point. 0.96. What is the ratio of the Total Labor Force (in %) in Arab World in 2002 to that in 2004?
Ensure brevity in your answer.  0.96. What is the ratio of the Total Labor Force (in %) in Latin America(developing only) in 2002 to that in 2004?
Your response must be concise. 0.98. What is the ratio of the Total Labor Force (in %) in Cote d'Ivoire in 2002 to that in 2004?
Make the answer very short. 0.99. What is the ratio of the Total Labor Force (in %) of Qatar in 2002 to that in 2004?
Your response must be concise. 0.95. What is the ratio of the Total Labor Force (in %) in Arab World in 2002 to that in 2005?
Give a very brief answer. 0.95. What is the ratio of the Total Labor Force (in %) of Latin America(developing only) in 2002 to that in 2005?
Give a very brief answer. 0.97. What is the ratio of the Total Labor Force (in %) of Cote d'Ivoire in 2002 to that in 2005?
Make the answer very short. 0.98. What is the ratio of the Total Labor Force (in %) of Qatar in 2002 to that in 2005?
Your response must be concise. 0.89. What is the ratio of the Total Labor Force (in %) in Arab World in 2002 to that in 2006?
Make the answer very short. 0.94. What is the ratio of the Total Labor Force (in %) in Latin America(developing only) in 2002 to that in 2006?
Offer a terse response. 0.96. What is the ratio of the Total Labor Force (in %) in Cote d'Ivoire in 2002 to that in 2006?
Provide a succinct answer. 0.97. What is the ratio of the Total Labor Force (in %) in Qatar in 2002 to that in 2006?
Your answer should be very brief. 0.83. What is the ratio of the Total Labor Force (in %) in Arab World in 2002 to that in 2007?
Your answer should be compact. 0.91. What is the ratio of the Total Labor Force (in %) in Latin America(developing only) in 2002 to that in 2007?
Your answer should be compact. 0.96. What is the ratio of the Total Labor Force (in %) in Cote d'Ivoire in 2002 to that in 2007?
Provide a succinct answer. 0.97. What is the ratio of the Total Labor Force (in %) in Qatar in 2002 to that in 2007?
Keep it short and to the point. 0.79. What is the ratio of the Total Labor Force (in %) of Arab World in 2003 to that in 2004?
Give a very brief answer. 0.98. What is the ratio of the Total Labor Force (in %) in Qatar in 2003 to that in 2004?
Your response must be concise. 0.98. What is the ratio of the Total Labor Force (in %) of Arab World in 2003 to that in 2005?
Your response must be concise. 0.97. What is the ratio of the Total Labor Force (in %) of Latin America(developing only) in 2003 to that in 2005?
Your response must be concise. 0.97. What is the ratio of the Total Labor Force (in %) of Cote d'Ivoire in 2003 to that in 2005?
Give a very brief answer. 0.99. What is the ratio of the Total Labor Force (in %) of Qatar in 2003 to that in 2005?
Ensure brevity in your answer.  0.92. What is the ratio of the Total Labor Force (in %) in Arab World in 2003 to that in 2006?
Provide a short and direct response. 0.97. What is the ratio of the Total Labor Force (in %) in Latin America(developing only) in 2003 to that in 2006?
Provide a succinct answer. 0.97. What is the ratio of the Total Labor Force (in %) of Cote d'Ivoire in 2003 to that in 2006?
Provide a succinct answer. 0.98. What is the ratio of the Total Labor Force (in %) of Qatar in 2003 to that in 2006?
Your answer should be compact. 0.86. What is the ratio of the Total Labor Force (in %) in Arab World in 2003 to that in 2007?
Provide a succinct answer. 0.94. What is the ratio of the Total Labor Force (in %) of Latin America(developing only) in 2003 to that in 2007?
Your answer should be compact. 0.96. What is the ratio of the Total Labor Force (in %) in Cote d'Ivoire in 2003 to that in 2007?
Offer a very short reply. 0.97. What is the ratio of the Total Labor Force (in %) of Qatar in 2003 to that in 2007?
Your answer should be compact. 0.82. What is the ratio of the Total Labor Force (in %) in Arab World in 2004 to that in 2005?
Offer a very short reply. 0.99. What is the ratio of the Total Labor Force (in %) in Latin America(developing only) in 2004 to that in 2005?
Make the answer very short. 0.99. What is the ratio of the Total Labor Force (in %) of Qatar in 2004 to that in 2005?
Offer a terse response. 0.94. What is the ratio of the Total Labor Force (in %) in Arab World in 2004 to that in 2006?
Ensure brevity in your answer.  0.98. What is the ratio of the Total Labor Force (in %) in Latin America(developing only) in 2004 to that in 2006?
Your response must be concise. 0.98. What is the ratio of the Total Labor Force (in %) of Cote d'Ivoire in 2004 to that in 2006?
Provide a short and direct response. 0.99. What is the ratio of the Total Labor Force (in %) in Qatar in 2004 to that in 2006?
Your answer should be very brief. 0.88. What is the ratio of the Total Labor Force (in %) of Latin America(developing only) in 2004 to that in 2007?
Your response must be concise. 0.98. What is the ratio of the Total Labor Force (in %) in Cote d'Ivoire in 2004 to that in 2007?
Make the answer very short. 0.98. What is the ratio of the Total Labor Force (in %) in Qatar in 2004 to that in 2007?
Make the answer very short. 0.84. What is the ratio of the Total Labor Force (in %) in Arab World in 2005 to that in 2006?
Offer a very short reply. 1. What is the ratio of the Total Labor Force (in %) in Qatar in 2005 to that in 2006?
Ensure brevity in your answer.  0.94. What is the ratio of the Total Labor Force (in %) in Arab World in 2005 to that in 2007?
Your answer should be compact. 0.96. What is the ratio of the Total Labor Force (in %) in Cote d'Ivoire in 2005 to that in 2007?
Provide a succinct answer. 0.99. What is the ratio of the Total Labor Force (in %) of Qatar in 2005 to that in 2007?
Your answer should be compact. 0.89. What is the ratio of the Total Labor Force (in %) in Arab World in 2006 to that in 2007?
Offer a terse response. 0.97. What is the ratio of the Total Labor Force (in %) in Qatar in 2006 to that in 2007?
Provide a short and direct response. 0.95. What is the difference between the highest and the second highest Total Labor Force (in %) of Arab World?
Give a very brief answer. 0.72. What is the difference between the highest and the second highest Total Labor Force (in %) of Latin America(developing only)?
Your answer should be compact. 0.39. What is the difference between the highest and the second highest Total Labor Force (in %) of Cote d'Ivoire?
Keep it short and to the point. 0.3. What is the difference between the highest and the lowest Total Labor Force (in %) in Arab World?
Your answer should be compact. 1.96. What is the difference between the highest and the lowest Total Labor Force (in %) in Latin America(developing only)?
Provide a succinct answer. 3.11. What is the difference between the highest and the lowest Total Labor Force (in %) of Cote d'Ivoire?
Ensure brevity in your answer.  1.9. What is the difference between the highest and the lowest Total Labor Force (in %) in Qatar?
Offer a terse response. 11. 